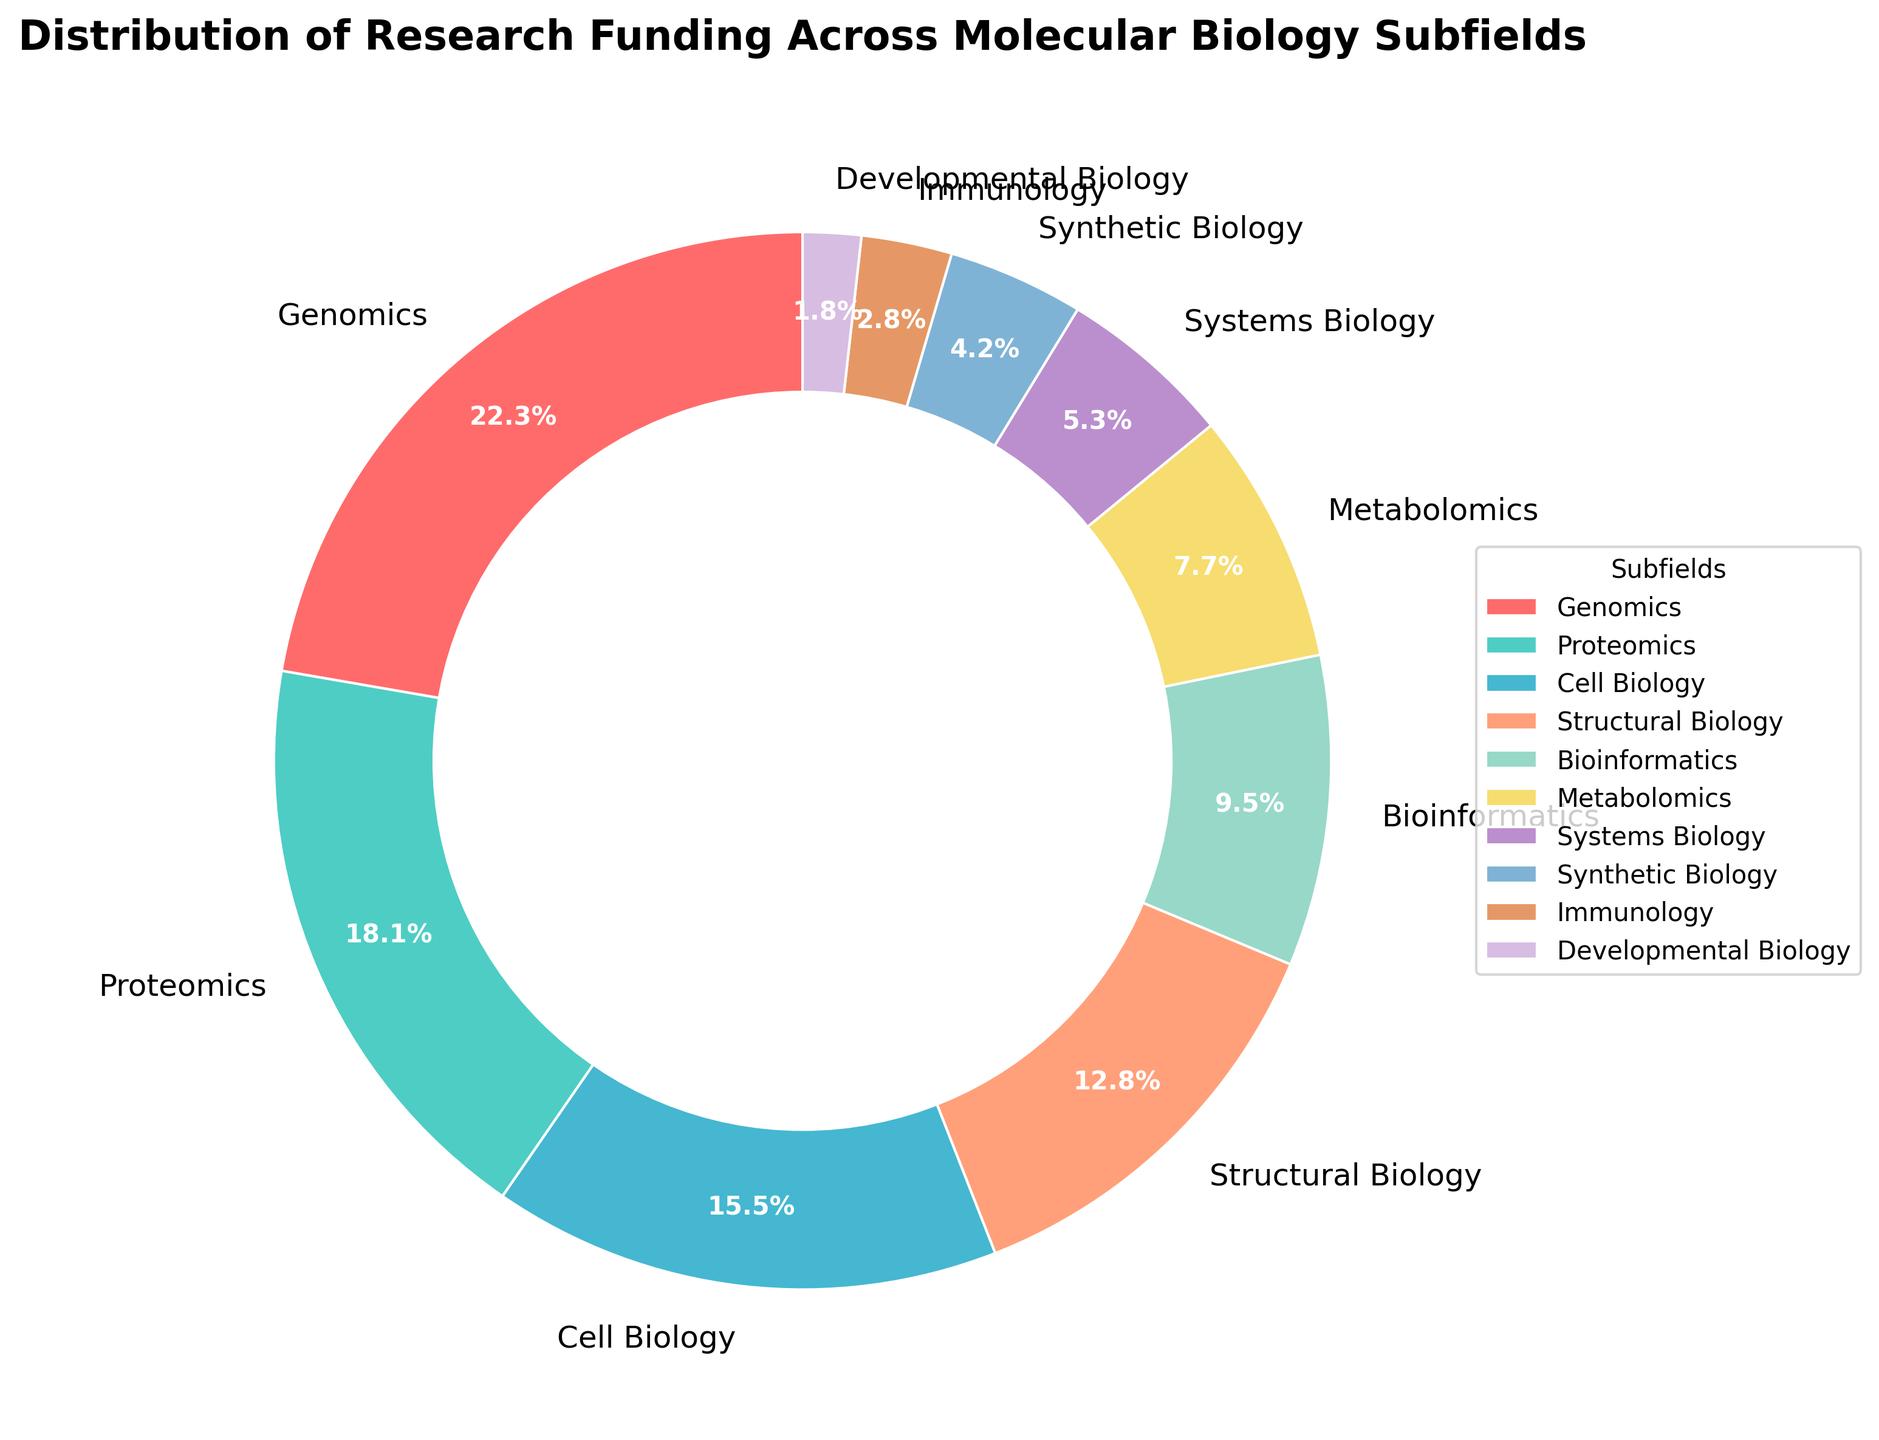What percentage of research funding is allocated to Genomics? By examining the pie chart, it shows the specific percentage values for each subfield. The label for Genomics indicates that it receives 22.5% of the funding.
Answer: 22.5% Which subfield receives the least amount of research funding? The pie chart labels each subfield with its corresponding funding percentage. Immunology, with a funding percentage of 2.8%, and Developmental Biology, with 1.8%, are the candidates. The least funding goes to Developmental Biology as 1.8% is less than 2.8%.
Answer: Developmental Biology What is the total percentage of research funding received by Genomics and Proteomics combined? The pie chart shows the individual percentages for each subfield. Adding the percentages for Genomics (22.5%) and Proteomics (18.3%), we get 22.5 + 18.3 = 40.8.
Answer: 40.8% What is the difference in funding percentage between Bioinformatics and Systems Biology? The pie chart provides the funding percentages for each subfield. Bioinformatics has 9.6%, and Systems Biology has 5.4%. Subtracting these gives 9.6 - 5.4 = 4.2.
Answer: 4.2% Which subfield receives more funding, Synthetic Biology or Structural Biology, and by how much? According to the pie chart, Synthetic Biology receives 4.2% of the funding, and Structural Biology receives 12.9%. The difference is 12.9 - 4.2 = 8.7, indicating Structural Biology receives more funding.
Answer: Structural Biology by 8.7% What is the combined funding percentage for the subfields with the lowest 4 fundings? The lowest 4 subfields are Immunology (2.8%), Developmental Biology (1.8%), Systems Biology (5.4%), and Synthetic Biology (4.2%). Adding these percentages, we get 2.8 + 1.8 + 5.4 + 4.2 = 14.2.
Answer: 14.2% Which subfield has a higher funding percentage, Cell Biology or Bioinformatics? The pie chart shows that Cell Biology has 15.7% funding, and Bioinformatics has 9.6%. Therefore, Cell Biology has a higher funding percentage.
Answer: Cell Biology What percentage of research funding is allocated to the subfields that cumulatively receive more than 50% funding? The subfields with individual percentages adding up to more than 50% are Genomics (22.5%), Proteomics (18.3%), and Cell Biology (15.7%). Adding these gives 22.5 + 18.3 + 15.7 = 56.5, which is more than 50%.
Answer: 56.5% What is the average funding percentage of Metabolomics and Structural Biology? According to the pie chart, Metabolomics has 7.8% funding, and Structural Biology has 12.9%. The average is (7.8 + 12.9) / 2 = 10.35.
Answer: 10.35 What color represents Proteomics in the pie chart? The pie chart visually associates colors with each subfield. Proteomics is associated with the second listed color, which is light green.
Answer: Light green 